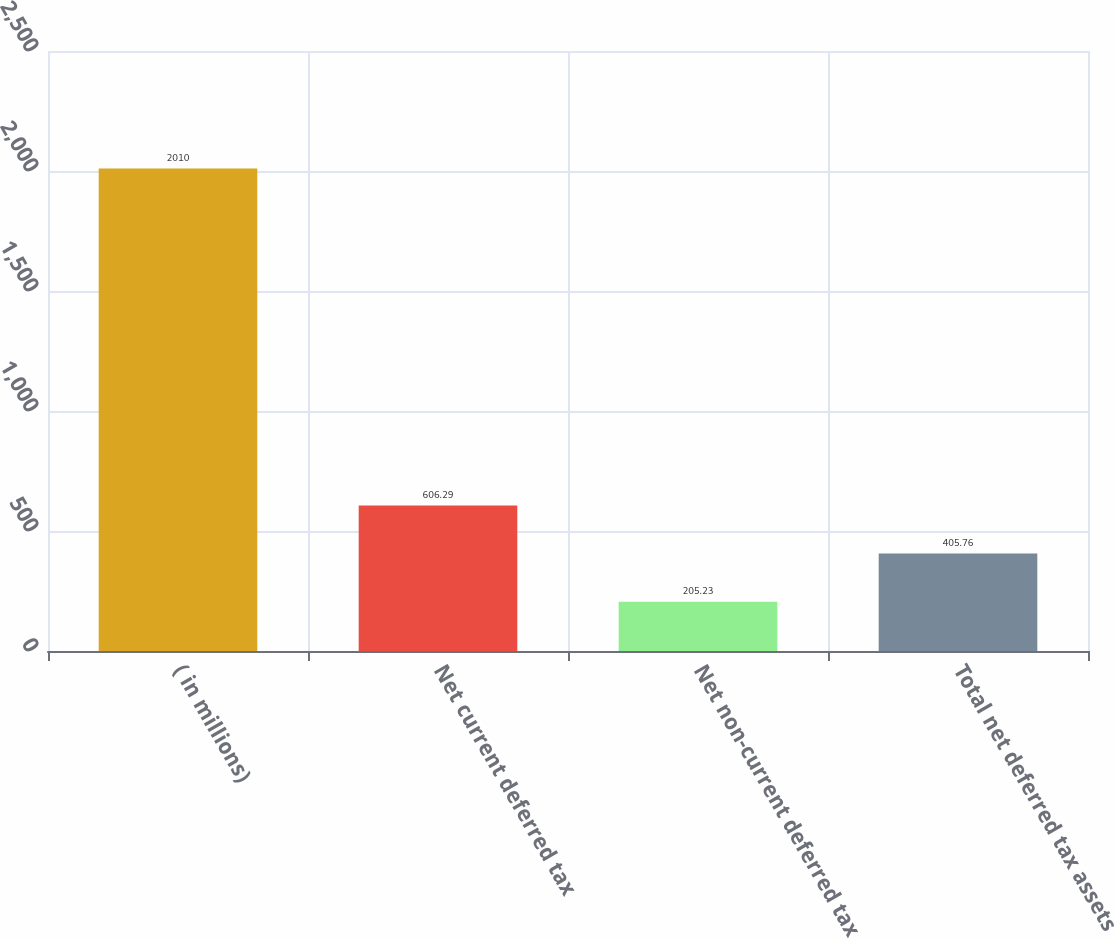<chart> <loc_0><loc_0><loc_500><loc_500><bar_chart><fcel>( in millions)<fcel>Net current deferred tax<fcel>Net non-current deferred tax<fcel>Total net deferred tax assets<nl><fcel>2010<fcel>606.29<fcel>205.23<fcel>405.76<nl></chart> 